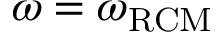<formula> <loc_0><loc_0><loc_500><loc_500>\omega = \omega _ { R C M }</formula> 